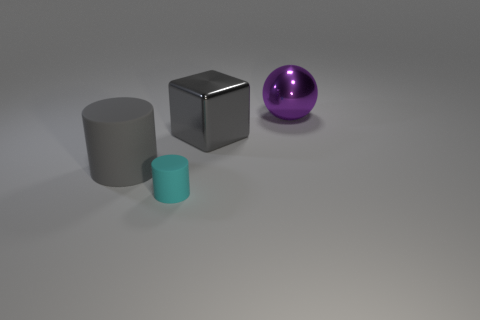Is there anything else that is the same size as the cyan matte cylinder?
Keep it short and to the point. No. How many other things are the same size as the purple metal thing?
Offer a terse response. 2. There is a shiny object to the left of the big purple metal ball on the right side of the big gray metal block; what is its color?
Offer a terse response. Gray. How many other objects are the same shape as the gray matte thing?
Offer a very short reply. 1. Is there a tiny cylinder made of the same material as the big cylinder?
Provide a succinct answer. Yes. There is a gray cylinder that is the same size as the ball; what is its material?
Ensure brevity in your answer.  Rubber. There is a shiny thing that is in front of the big thing that is behind the metal thing in front of the large purple object; what is its color?
Keep it short and to the point. Gray. There is a large thing that is to the left of the cyan cylinder; is its shape the same as the tiny cyan rubber object on the left side of the big gray shiny block?
Provide a succinct answer. Yes. How many big rubber objects are there?
Your answer should be compact. 1. There is another metal object that is the same size as the purple object; what color is it?
Offer a very short reply. Gray. 